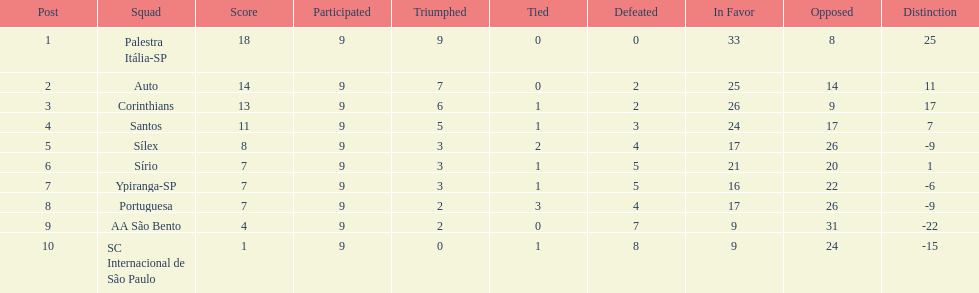How many points did the brazilian football team auto get in 1926? 14. I'm looking to parse the entire table for insights. Could you assist me with that? {'header': ['Post', 'Squad', 'Score', 'Participated', 'Triumphed', 'Tied', 'Defeated', 'In Favor', 'Opposed', 'Distinction'], 'rows': [['1', 'Palestra Itália-SP', '18', '9', '9', '0', '0', '33', '8', '25'], ['2', 'Auto', '14', '9', '7', '0', '2', '25', '14', '11'], ['3', 'Corinthians', '13', '9', '6', '1', '2', '26', '9', '17'], ['4', 'Santos', '11', '9', '5', '1', '3', '24', '17', '7'], ['5', 'Sílex', '8', '9', '3', '2', '4', '17', '26', '-9'], ['6', 'Sírio', '7', '9', '3', '1', '5', '21', '20', '1'], ['7', 'Ypiranga-SP', '7', '9', '3', '1', '5', '16', '22', '-6'], ['8', 'Portuguesa', '7', '9', '2', '3', '4', '17', '26', '-9'], ['9', 'AA São Bento', '4', '9', '2', '0', '7', '9', '31', '-22'], ['10', 'SC Internacional de São Paulo', '1', '9', '0', '1', '8', '9', '24', '-15']]} 